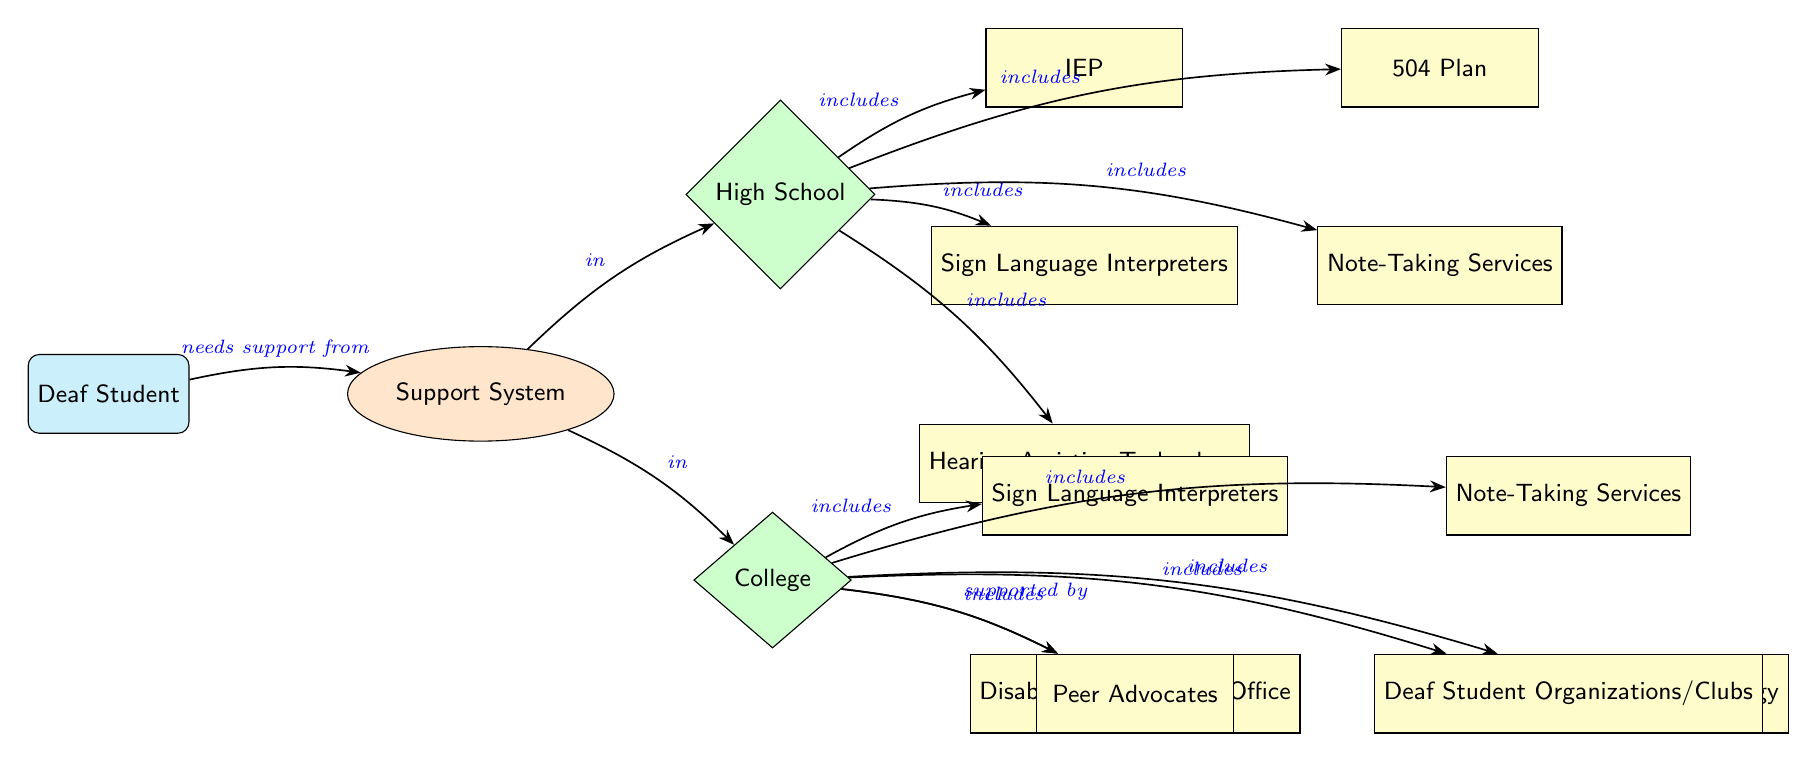What is the support system for a deaf student called in the diagram? The diagram identifies the overall support system specifically as "Support System." This can be determined by looking at the node that directly connects to the "Deaf Student" node.
Answer: Support System How many services are listed under high school? There are five services listed under the "High School" node, which include IEP, 504 Plan, Sign Language Interpreters, Note-Taking Services, and Hearing Assistive Technology. This count is derived from evaluating each edge leading into the "High School" node.
Answer: 5 What is one of the services available in college for deaf students? One of the services available in college is the "Disability/Accessibility Office." This can be confirmed by identifying the edges leading out from the "College" node, which includes this service among others.
Answer: Disability/Accessibility Office Do college support systems include peer advocates? Yes, the college support systems include "Peer Advocates." This can be concluded by tracking the edges from the "College" node to the services it encompasses, where "Peer Advocates" is listed.
Answer: Yes What kind of service is IEP categorized as in the diagram? The IEP is categorized as a "Service," indicated by its placement within the box shape labeled as a service node immediately under "High School." This is determined by checking its visual representation in the diagram.
Answer: Service What relationships can be observed between high school and college concerning support systems? The relationship observed is that both support systems provide different but corresponding services; while both include Sign Language Interpreters and Note-Taking Services, high school has specific items like IEP and 504 Plans, whereas college includes disability offices and peer advocates. This is deduced by comparing the nodes and their connections under high school and college.
Answer: Corresponding services How many different types of services are available in college? The college has five distinct types of services available: Disability/Accessibility Office, Sign Language Interpreters, Note-Taking Services, Hearing Assistive Technology, and Peer Advocates. This is assessed by counting how many distinct service nodes are linked under the "College" node.
Answer: 5 Which service is only available for high school students and not college students? The "IEP" (Individualized Education Program) is exclusively available for high school students, as it is listed directly under the high school services but not represented in the college services. This is established by reviewing the nodes that are unique to each educational level in the diagram.
Answer: IEP Are hearing assistive technology services provided at both levels of education? Yes, "Hearing Assistive Technology" services are provided at both high school and college levels as indicated by the edges that lead to and from the respective nodes under each educational level. This is verified by tracing the paths leading from both the high school and college nodes.
Answer: Yes 